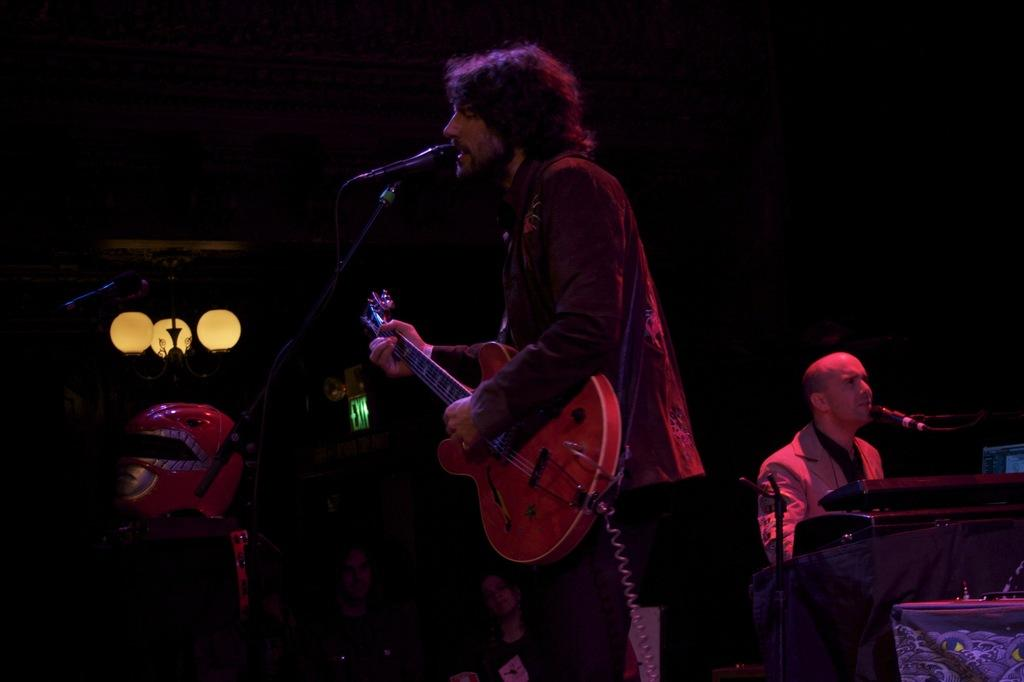What is the man in the image doing? The man is playing a guitar and singing. How is the man's voice being amplified in the image? The man is using a microphone. What type of can is visible in the image? There is no can present in the image. Is the man taking a flight while playing the guitar in the image? There is no indication of a flight or any transportation in the image; it simply shows a man playing a guitar and singing. 